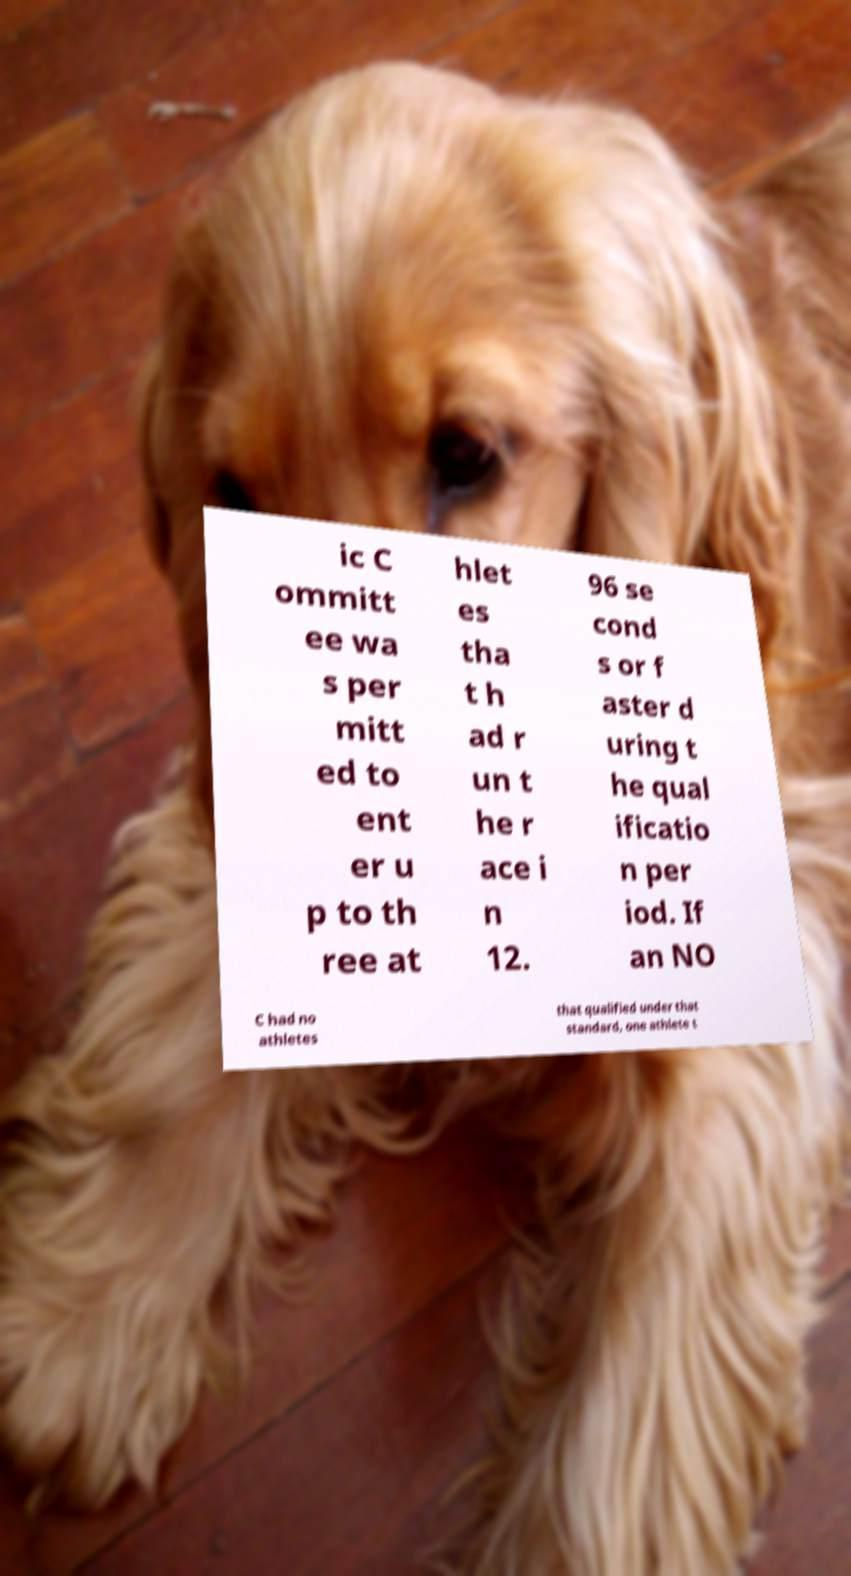For documentation purposes, I need the text within this image transcribed. Could you provide that? ic C ommitt ee wa s per mitt ed to ent er u p to th ree at hlet es tha t h ad r un t he r ace i n 12. 96 se cond s or f aster d uring t he qual ificatio n per iod. If an NO C had no athletes that qualified under that standard, one athlete t 